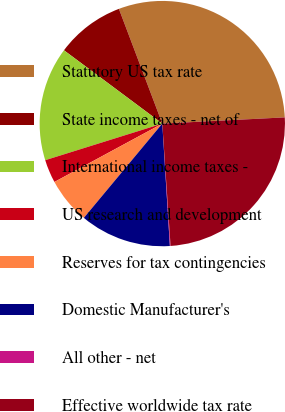Convert chart. <chart><loc_0><loc_0><loc_500><loc_500><pie_chart><fcel>Statutory US tax rate<fcel>State income taxes - net of<fcel>International income taxes -<fcel>US research and development<fcel>Reserves for tax contingencies<fcel>Domestic Manufacturer's<fcel>All other - net<fcel>Effective worldwide tax rate<nl><fcel>29.95%<fcel>9.05%<fcel>15.02%<fcel>3.07%<fcel>6.06%<fcel>12.03%<fcel>0.09%<fcel>24.73%<nl></chart> 